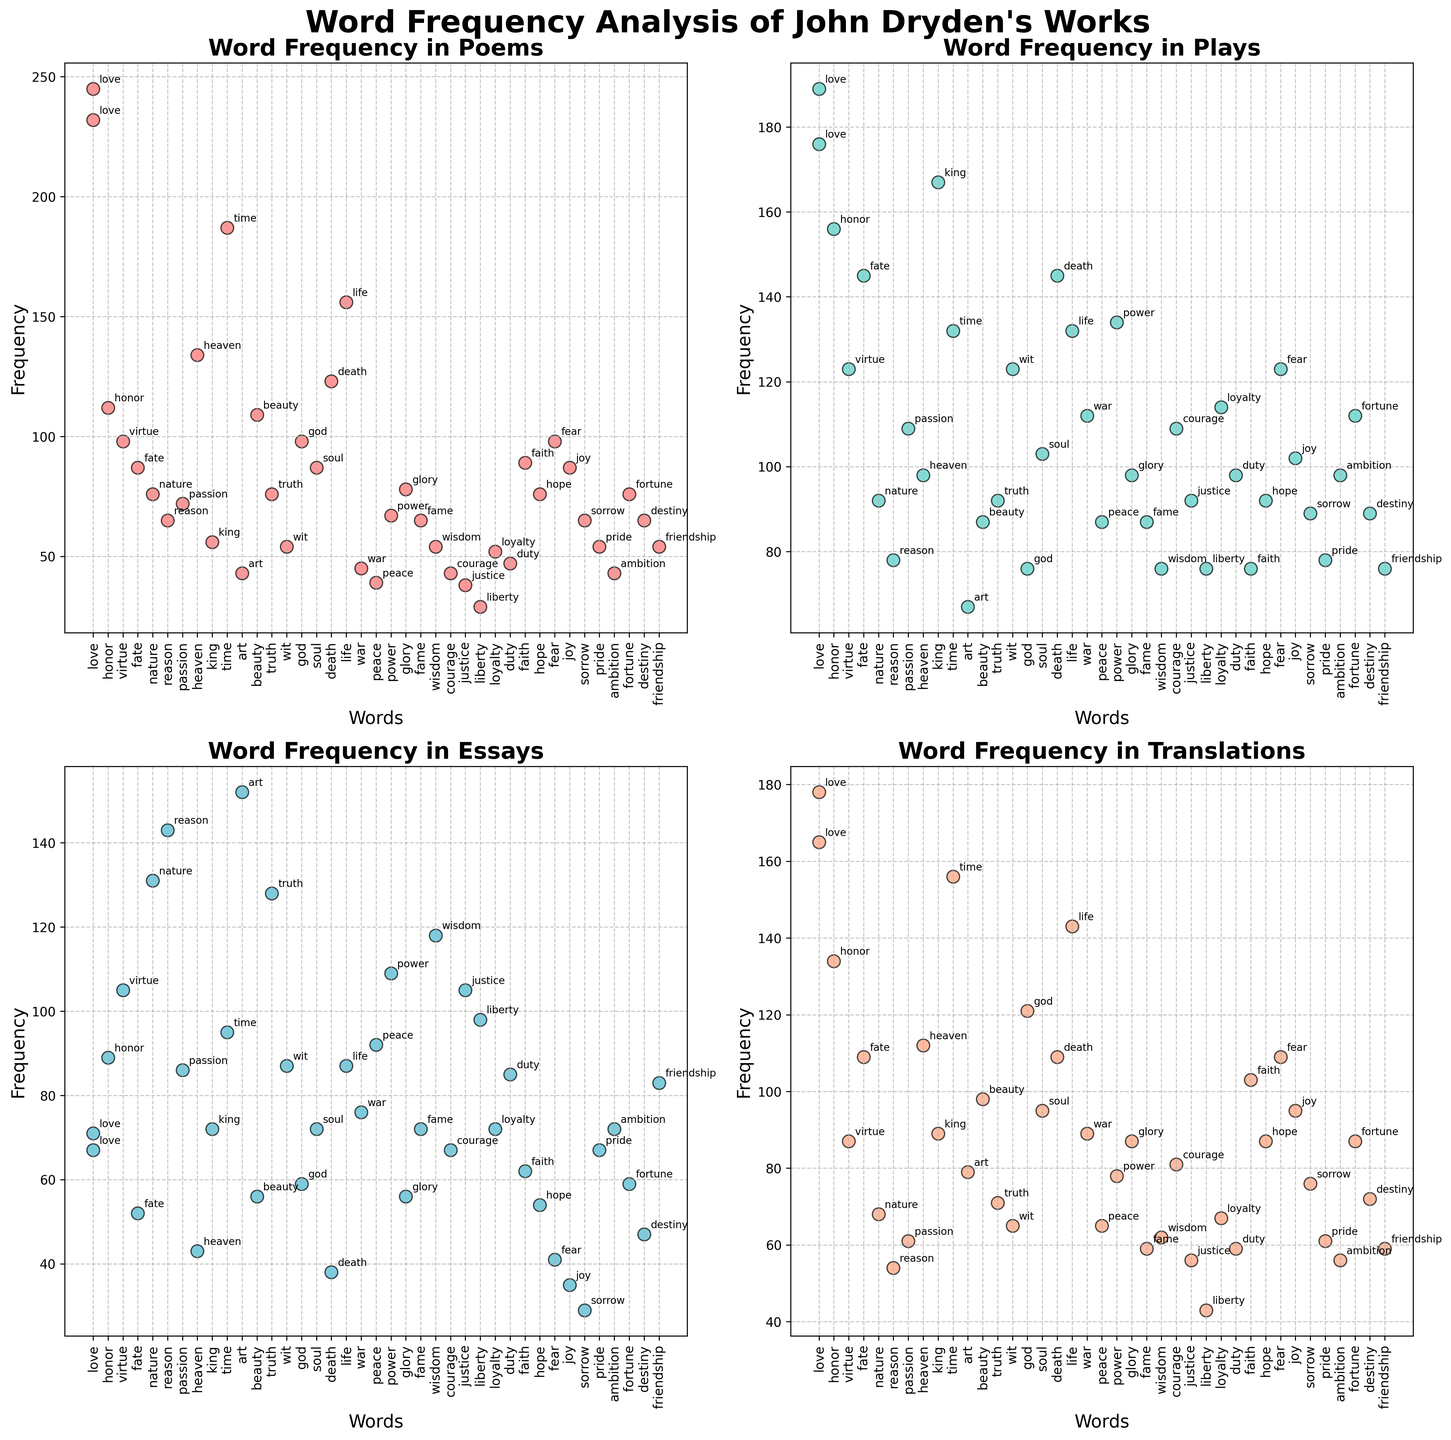Which genre has the highest frequency for the word 'love'? The subplot for each genre shows the frequency of words. For 'love', the frequency values are 245 in poems, 189 in plays, 67 in essays, and 178 in translations. The highest frequency is in poems.
Answer: poems What is the average frequency of the word 'reason' across all genres? The frequencies of 'reason' are 65 in poems, 78 in plays, 143 in essays, and 54 in translations. The sum is 65 + 78 + 143 + 54 = 340. The average is 340 / 4 = 85.
Answer: 85 Which word has the lowest frequency in plays? By examining the scatter plot for plays, the word with the lowest frequency is 'liberty' with a frequency of 76.
Answer: liberty Compare the frequencies of the word 'fate' in poems and translations. Which one is higher? The subplot for poems shows the frequency of 'fate' is 87, and for translations, it is 109. Comparing these values, translations have a higher frequency.
Answer: translations What is the total frequency of the word 'honor' in plays and translations combined? The frequency of 'honor' in plays is 156, and in translations, it is 134. Summing these gives 156 + 134 = 290.
Answer: 290 Which words appear more frequently in essays than in any other genre? For essays, we need to compare the frequency of each word against its frequencies in poems, plays, and translations. 'art' appears more frequently in essays (152) than in any other genre (43 in poems, 67 in plays, 79 in translations).
Answer: art Which word has the same frequency in poems and essays? By comparing the word frequencies in both plots, 'friendship' has the same frequency of 54 in both poems and essays.
Answer: friendship How does the frequency of the word 'virtue' in translations compare to poems and plays? The frequency of 'virtue' in translations is 87, in poems, it is 98, and in plays, it is 123. 'Virtue' appears less frequently in translations than in both poems and plays.
Answer: less 